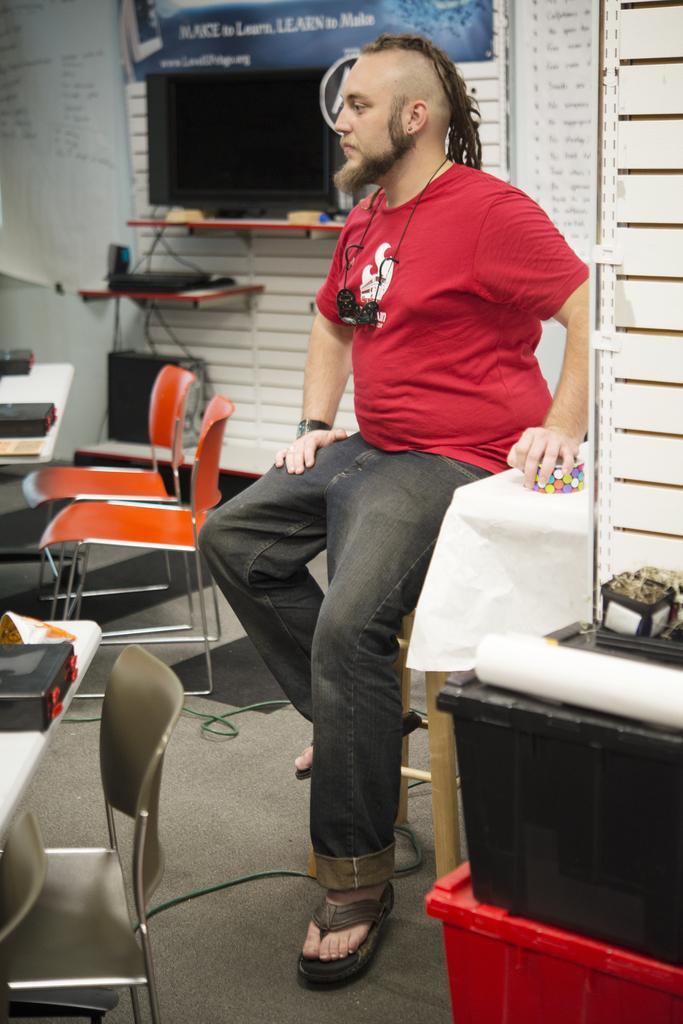Can you describe this image briefly? In the center we can see one person sitting on stool. Around him we can see tables,chair,monitor,wall,board and few more objects. 